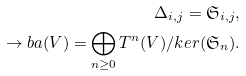<formula> <loc_0><loc_0><loc_500><loc_500>\Delta _ { i , j } = \mathfrak S _ { i , j } , \\ \to b a ( V ) = \bigoplus _ { n \geq 0 } T ^ { n } ( V ) / k e r ( \mathfrak { S } _ { n } ) .</formula> 